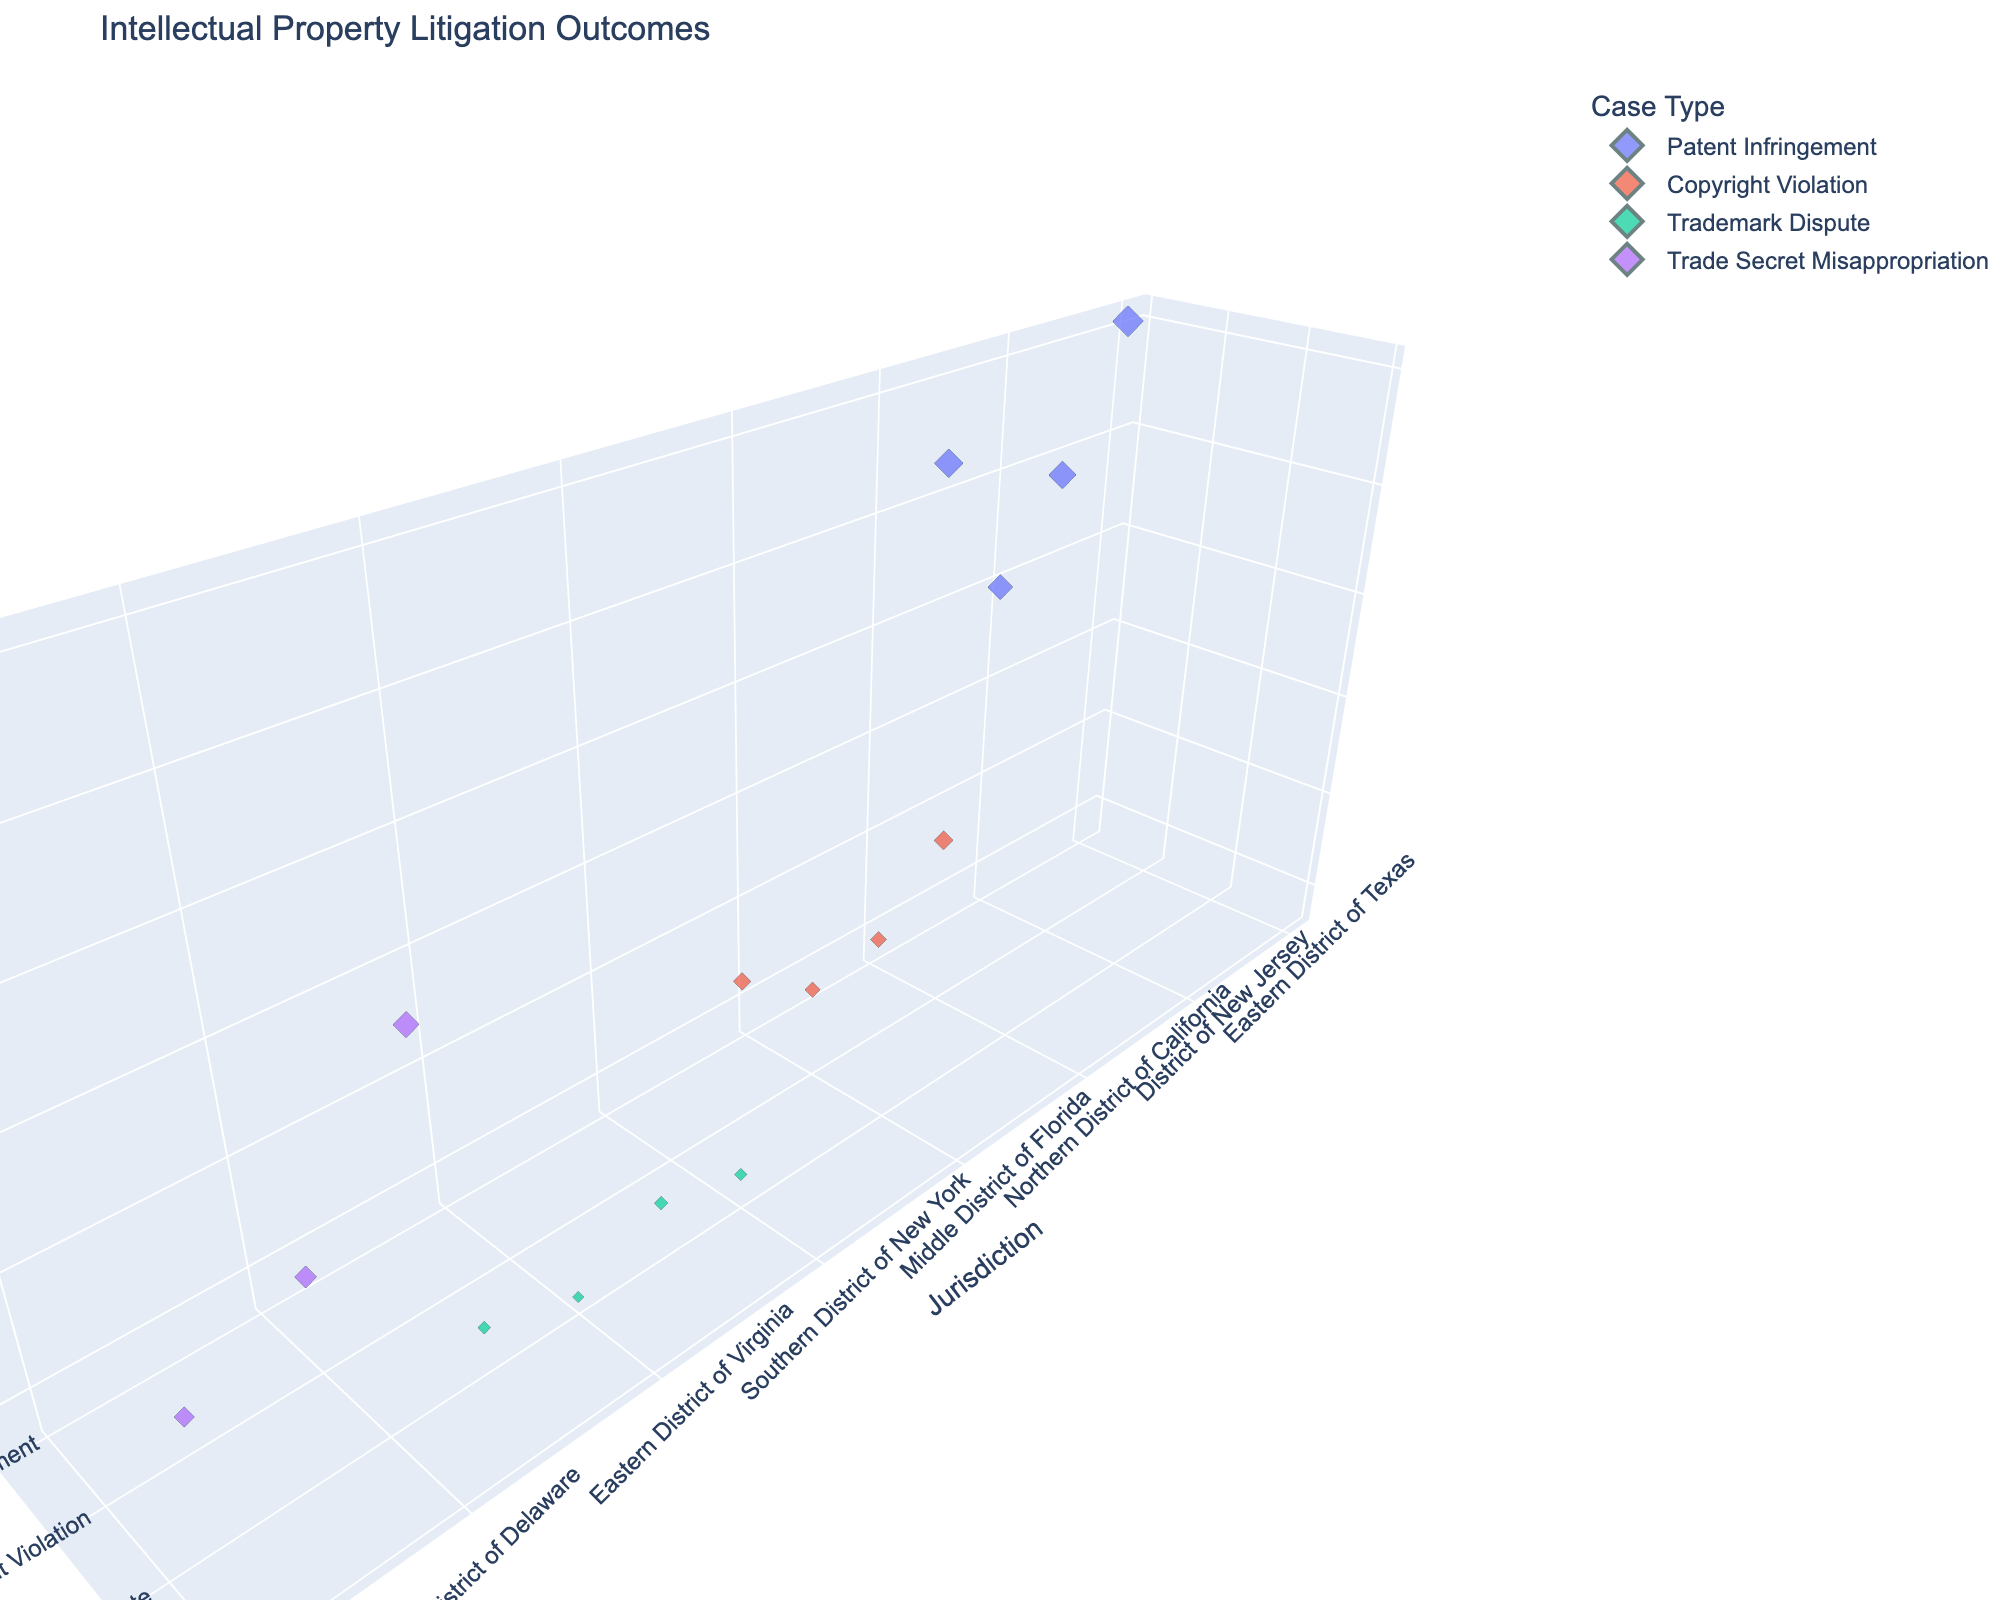What is the title of the 3D scatter plot? The title is displayed at the top of the 3D scatter plot, summarizing the purpose of the visualization.
Answer: Intellectual Property Litigation Outcomes How many different jurisdictions are represented in the 3D scatter plot? Each unique jurisdiction on the x-axis represents a different geographical region where the litigation occurred.
Answer: 14 Which jurisdiction had the highest monetary award and for which case type? By examining the z-axis for the highest value and checking the corresponding x-axis and y-axis labels, we can determine the jurisdiction and case type.
Answer: Eastern District of Texas, Patent Infringement What are the case types shown in the 3D scatter plot? The y-axis labels represent the different types of cases included in the plot.
Answer: Patent Infringement, Copyright Violation, Trademark Dispute, Trade Secret Misappropriation Compare the monetary awards for Patent Infringement cases across different jurisdictions. Which jurisdiction had the highest and the lowest awards? By identifying the data points categorized under Patent Infringement and inspecting their corresponding z-axis values (monetary awards), we can determine the highest and lowest awards.
Answer: Highest: Eastern District of Texas; Lowest: District of New Jersey Which case type had the most frequent occurrences in the plot? By counting the number of data points per case type (identified by color and y-axis labels), we can determine which appears most frequently.
Answer: Patent Infringement In which jurisdiction did a Copyright Violation case result in the highest monetary award? By examining the data points labeled as Copyright Violation and noting their z-axis values, we determine the jurisdiction with the highest value.
Answer: Northern District of California 